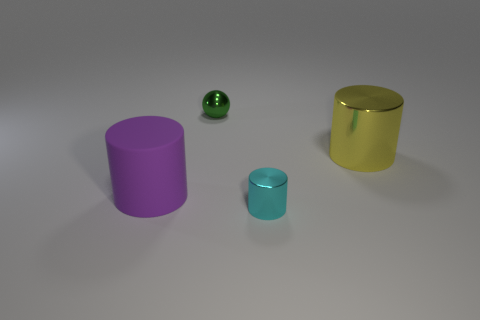There is a cylinder that is both on the right side of the big purple thing and on the left side of the big yellow metal object; what is its color?
Your answer should be compact. Cyan. Is the big cylinder right of the small green metallic thing made of the same material as the cyan cylinder?
Offer a terse response. Yes. Is the number of cyan cylinders behind the ball less than the number of cyan shiny blocks?
Ensure brevity in your answer.  No. Is there a small red ball that has the same material as the small cylinder?
Offer a very short reply. No. There is a cyan cylinder; is it the same size as the cylinder that is to the left of the tiny sphere?
Your answer should be compact. No. Do the green object and the small cyan cylinder have the same material?
Provide a short and direct response. Yes. There is a small shiny cylinder; what number of yellow shiny things are to the right of it?
Give a very brief answer. 1. What is the object that is left of the cyan cylinder and right of the large rubber object made of?
Keep it short and to the point. Metal. What number of other metallic balls are the same size as the green shiny ball?
Your answer should be very brief. 0. There is a object that is left of the object behind the big yellow cylinder; what color is it?
Keep it short and to the point. Purple. 